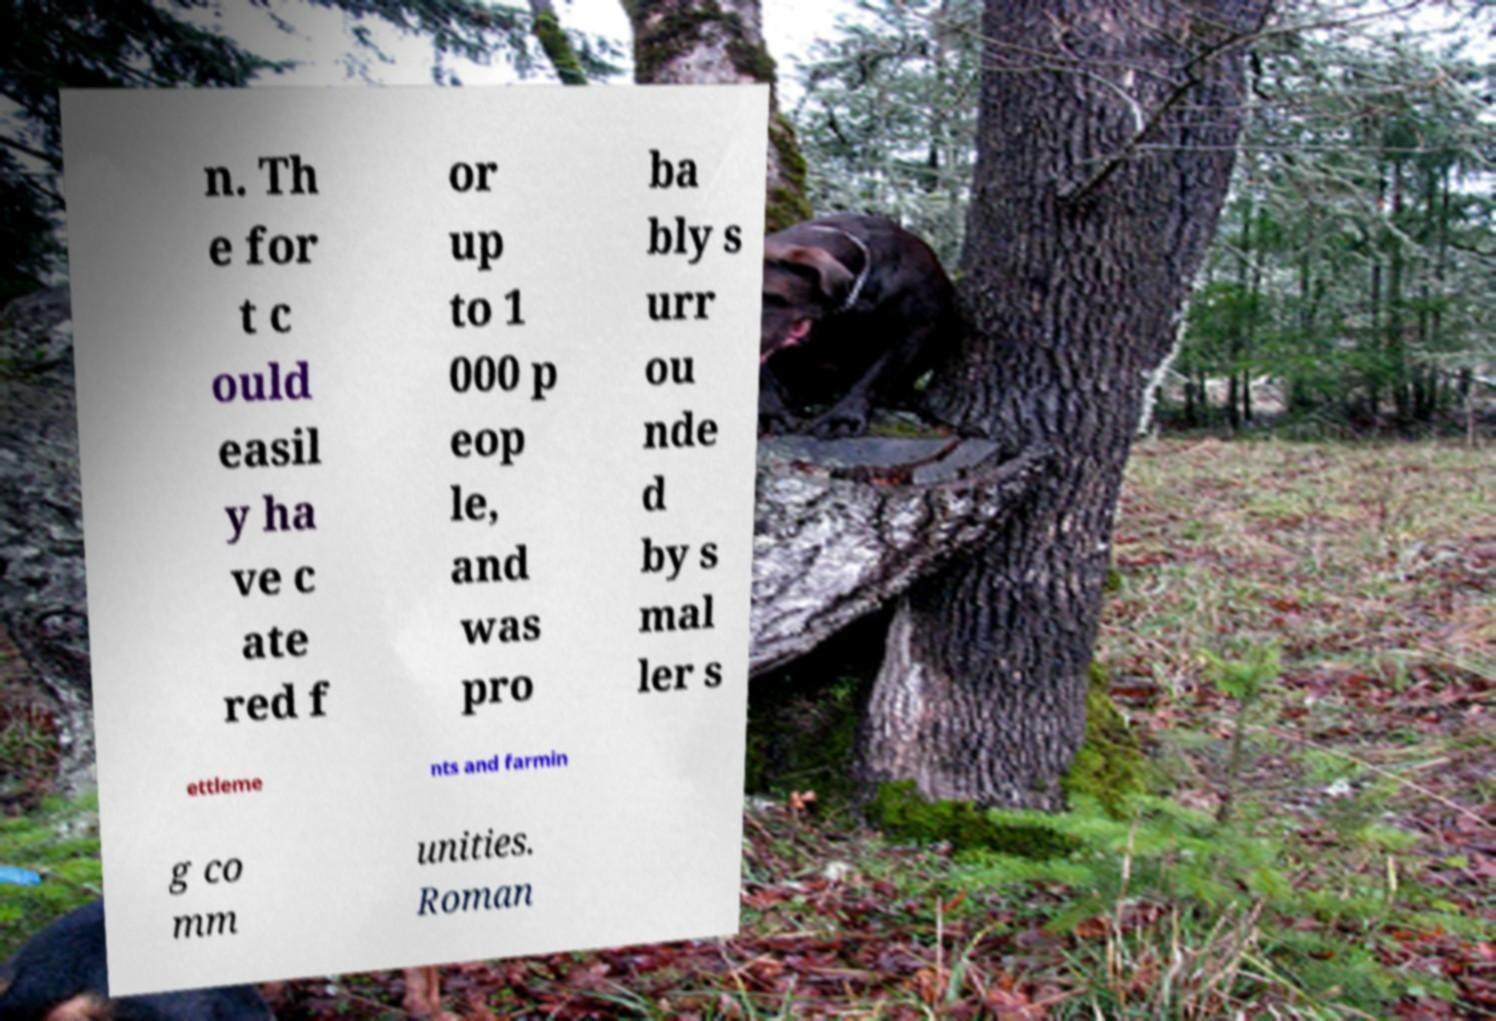Can you accurately transcribe the text from the provided image for me? n. Th e for t c ould easil y ha ve c ate red f or up to 1 000 p eop le, and was pro ba bly s urr ou nde d by s mal ler s ettleme nts and farmin g co mm unities. Roman 